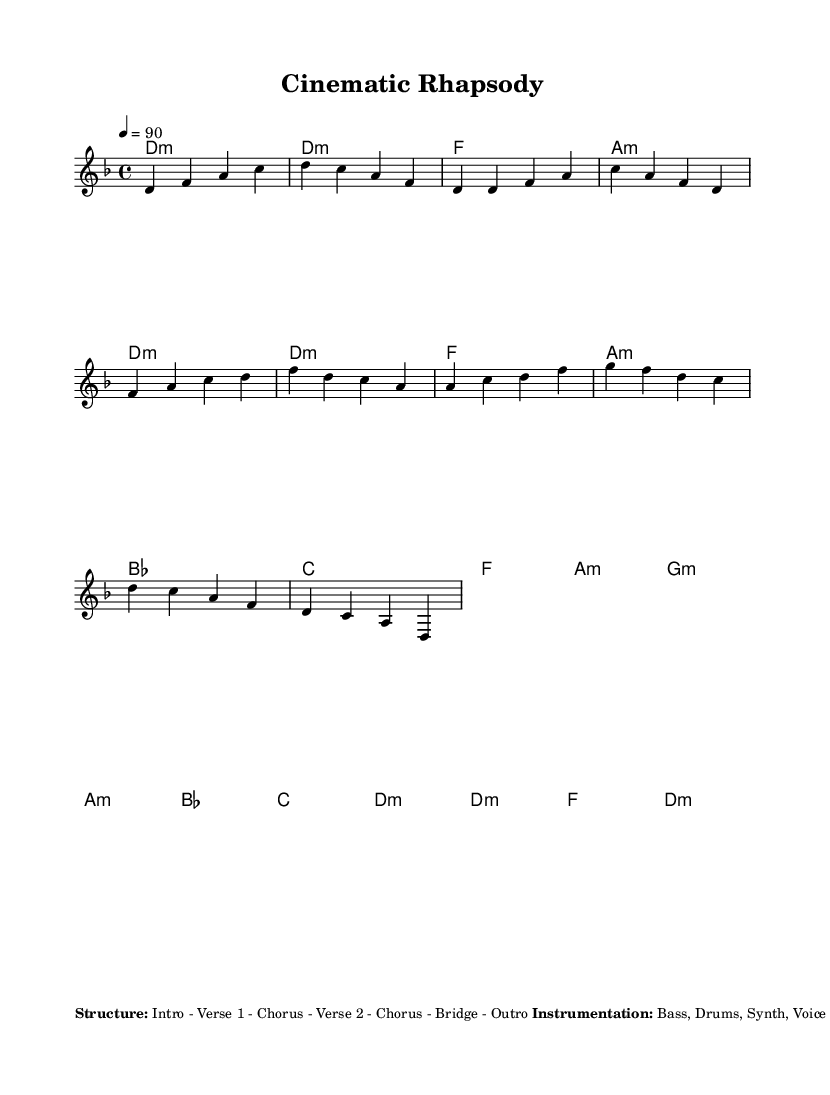What is the key signature of this music? The key signature is D minor, which includes one flat (B flat). This can be determined by looking at the key signature indicated at the beginning of the score.
Answer: D minor What is the time signature of the music? The time signature is 4/4, indicating there are four beats in each measure and the quarter note gets one beat. This is noted at the beginning of the score.
Answer: 4/4 What is the tempo marking for the piece? The tempo marking is indicated as 90 beats per minute. This is found in the tempo indication at the start of the score, which specifies how fast the piece should be played.
Answer: 90 How many distinct sections are in the structure of the music? The structure of the music includes six distinct sections: Intro, Verse, Chorus, Bridge, and Outro. This can be deduced from the structure described in the markup section of the score.
Answer: Six What type of instrument is primarily used to provide the melody? The melody is primarily provided by the Voice, as stated in the instrumentation section of the markup. This instrument typically delivers the rap verses and chorus lines.
Answer: Voice What sound effect appears during the Intro and Outro? The sound effect used in both the Intro and Outro is the movie projector, which adds a cinematic feel to the music. This is indicated in the sound effects section of the markup.
Answer: Movie projector Which dialogue sample is used before the Chorus? The dialogue sample that appears before the Chorus is "In a world". This specific line is listed in the dialogue samples section of the markup.
Answer: In a world 